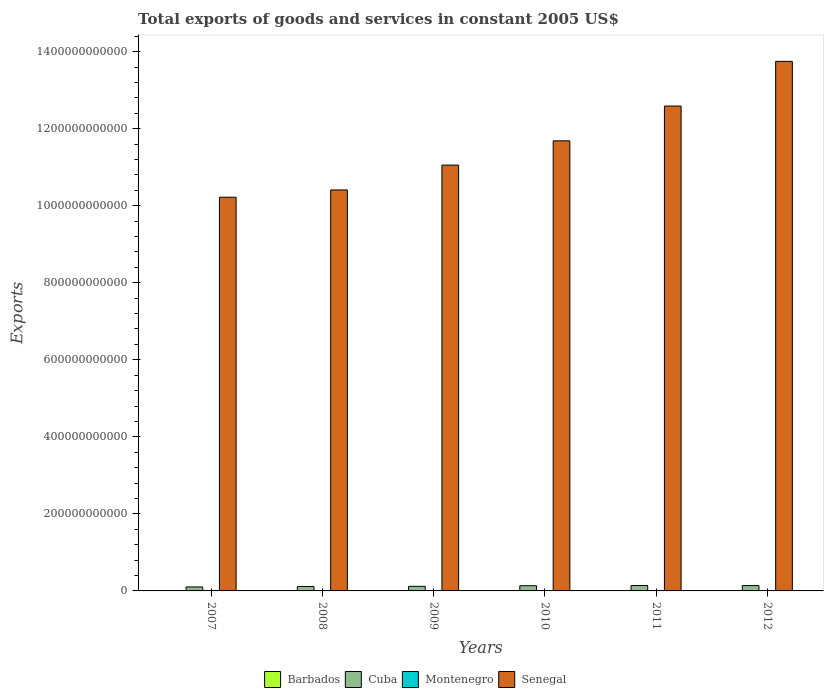How many groups of bars are there?
Keep it short and to the point. 6. Are the number of bars on each tick of the X-axis equal?
Ensure brevity in your answer.  Yes. How many bars are there on the 3rd tick from the left?
Offer a very short reply. 4. What is the label of the 5th group of bars from the left?
Keep it short and to the point. 2011. In how many cases, is the number of bars for a given year not equal to the number of legend labels?
Offer a very short reply. 0. What is the total exports of goods and services in Cuba in 2011?
Keep it short and to the point. 1.41e+1. Across all years, what is the maximum total exports of goods and services in Senegal?
Your answer should be very brief. 1.37e+12. Across all years, what is the minimum total exports of goods and services in Senegal?
Your response must be concise. 1.02e+12. In which year was the total exports of goods and services in Cuba maximum?
Your answer should be compact. 2011. What is the total total exports of goods and services in Senegal in the graph?
Make the answer very short. 6.97e+12. What is the difference between the total exports of goods and services in Cuba in 2007 and that in 2009?
Give a very brief answer. -1.56e+09. What is the difference between the total exports of goods and services in Cuba in 2007 and the total exports of goods and services in Senegal in 2008?
Your answer should be compact. -1.03e+12. What is the average total exports of goods and services in Barbados per year?
Ensure brevity in your answer.  7.30e+08. In the year 2009, what is the difference between the total exports of goods and services in Cuba and total exports of goods and services in Barbados?
Provide a succinct answer. 1.11e+1. What is the ratio of the total exports of goods and services in Barbados in 2010 to that in 2011?
Your response must be concise. 1.29. Is the difference between the total exports of goods and services in Cuba in 2009 and 2012 greater than the difference between the total exports of goods and services in Barbados in 2009 and 2012?
Your answer should be compact. No. What is the difference between the highest and the second highest total exports of goods and services in Barbados?
Ensure brevity in your answer.  2.30e+07. What is the difference between the highest and the lowest total exports of goods and services in Senegal?
Your answer should be very brief. 3.53e+11. Is it the case that in every year, the sum of the total exports of goods and services in Montenegro and total exports of goods and services in Barbados is greater than the sum of total exports of goods and services in Cuba and total exports of goods and services in Senegal?
Your response must be concise. Yes. What does the 2nd bar from the left in 2007 represents?
Provide a short and direct response. Cuba. What does the 1st bar from the right in 2012 represents?
Keep it short and to the point. Senegal. Are all the bars in the graph horizontal?
Keep it short and to the point. No. What is the difference between two consecutive major ticks on the Y-axis?
Keep it short and to the point. 2.00e+11. Are the values on the major ticks of Y-axis written in scientific E-notation?
Offer a terse response. No. Does the graph contain any zero values?
Give a very brief answer. No. Where does the legend appear in the graph?
Provide a short and direct response. Bottom center. How many legend labels are there?
Give a very brief answer. 4. How are the legend labels stacked?
Provide a succinct answer. Horizontal. What is the title of the graph?
Provide a short and direct response. Total exports of goods and services in constant 2005 US$. Does "Lithuania" appear as one of the legend labels in the graph?
Provide a short and direct response. No. What is the label or title of the X-axis?
Your response must be concise. Years. What is the label or title of the Y-axis?
Give a very brief answer. Exports. What is the Exports in Barbados in 2007?
Provide a short and direct response. 8.18e+08. What is the Exports in Cuba in 2007?
Make the answer very short. 1.03e+1. What is the Exports in Montenegro in 2007?
Your answer should be very brief. 9.66e+08. What is the Exports of Senegal in 2007?
Give a very brief answer. 1.02e+12. What is the Exports in Barbados in 2008?
Give a very brief answer. 7.82e+08. What is the Exports in Cuba in 2008?
Offer a terse response. 1.15e+1. What is the Exports of Montenegro in 2008?
Offer a terse response. 9.46e+08. What is the Exports of Senegal in 2008?
Your answer should be compact. 1.04e+12. What is the Exports in Barbados in 2009?
Offer a very short reply. 7.59e+08. What is the Exports in Cuba in 2009?
Provide a succinct answer. 1.19e+1. What is the Exports in Montenegro in 2009?
Give a very brief answer. 7.35e+08. What is the Exports of Senegal in 2009?
Your response must be concise. 1.11e+12. What is the Exports in Barbados in 2010?
Your answer should be very brief. 7.95e+08. What is the Exports of Cuba in 2010?
Your answer should be compact. 1.35e+1. What is the Exports in Montenegro in 2010?
Give a very brief answer. 7.90e+08. What is the Exports in Senegal in 2010?
Provide a short and direct response. 1.17e+12. What is the Exports of Barbados in 2011?
Provide a short and direct response. 6.14e+08. What is the Exports of Cuba in 2011?
Provide a succinct answer. 1.41e+1. What is the Exports of Montenegro in 2011?
Your answer should be compact. 9.05e+08. What is the Exports in Senegal in 2011?
Your response must be concise. 1.26e+12. What is the Exports of Barbados in 2012?
Ensure brevity in your answer.  6.13e+08. What is the Exports of Cuba in 2012?
Your response must be concise. 1.39e+1. What is the Exports of Montenegro in 2012?
Make the answer very short. 9.02e+08. What is the Exports in Senegal in 2012?
Your answer should be very brief. 1.37e+12. Across all years, what is the maximum Exports of Barbados?
Your answer should be very brief. 8.18e+08. Across all years, what is the maximum Exports of Cuba?
Give a very brief answer. 1.41e+1. Across all years, what is the maximum Exports in Montenegro?
Make the answer very short. 9.66e+08. Across all years, what is the maximum Exports of Senegal?
Offer a very short reply. 1.37e+12. Across all years, what is the minimum Exports in Barbados?
Your answer should be very brief. 6.13e+08. Across all years, what is the minimum Exports of Cuba?
Keep it short and to the point. 1.03e+1. Across all years, what is the minimum Exports of Montenegro?
Your answer should be very brief. 7.35e+08. Across all years, what is the minimum Exports in Senegal?
Provide a short and direct response. 1.02e+12. What is the total Exports of Barbados in the graph?
Your answer should be compact. 4.38e+09. What is the total Exports in Cuba in the graph?
Your answer should be compact. 7.52e+1. What is the total Exports in Montenegro in the graph?
Provide a succinct answer. 5.24e+09. What is the total Exports in Senegal in the graph?
Keep it short and to the point. 6.97e+12. What is the difference between the Exports in Barbados in 2007 and that in 2008?
Give a very brief answer. 3.60e+07. What is the difference between the Exports in Cuba in 2007 and that in 2008?
Offer a very short reply. -1.20e+09. What is the difference between the Exports in Montenegro in 2007 and that in 2008?
Your answer should be compact. 1.98e+07. What is the difference between the Exports of Senegal in 2007 and that in 2008?
Your response must be concise. -1.89e+1. What is the difference between the Exports in Barbados in 2007 and that in 2009?
Provide a short and direct response. 5.90e+07. What is the difference between the Exports of Cuba in 2007 and that in 2009?
Keep it short and to the point. -1.56e+09. What is the difference between the Exports of Montenegro in 2007 and that in 2009?
Offer a terse response. 2.31e+08. What is the difference between the Exports of Senegal in 2007 and that in 2009?
Ensure brevity in your answer.  -8.34e+1. What is the difference between the Exports of Barbados in 2007 and that in 2010?
Give a very brief answer. 2.30e+07. What is the difference between the Exports in Cuba in 2007 and that in 2010?
Offer a very short reply. -3.20e+09. What is the difference between the Exports in Montenegro in 2007 and that in 2010?
Give a very brief answer. 1.76e+08. What is the difference between the Exports in Senegal in 2007 and that in 2010?
Offer a terse response. -1.46e+11. What is the difference between the Exports in Barbados in 2007 and that in 2011?
Your response must be concise. 2.04e+08. What is the difference between the Exports in Cuba in 2007 and that in 2011?
Provide a short and direct response. -3.72e+09. What is the difference between the Exports of Montenegro in 2007 and that in 2011?
Your response must be concise. 6.07e+07. What is the difference between the Exports in Senegal in 2007 and that in 2011?
Ensure brevity in your answer.  -2.37e+11. What is the difference between the Exports in Barbados in 2007 and that in 2012?
Your response must be concise. 2.05e+08. What is the difference between the Exports of Cuba in 2007 and that in 2012?
Ensure brevity in your answer.  -3.57e+09. What is the difference between the Exports of Montenegro in 2007 and that in 2012?
Offer a terse response. 6.38e+07. What is the difference between the Exports of Senegal in 2007 and that in 2012?
Ensure brevity in your answer.  -3.53e+11. What is the difference between the Exports in Barbados in 2008 and that in 2009?
Ensure brevity in your answer.  2.30e+07. What is the difference between the Exports of Cuba in 2008 and that in 2009?
Give a very brief answer. -3.59e+08. What is the difference between the Exports in Montenegro in 2008 and that in 2009?
Your answer should be compact. 2.11e+08. What is the difference between the Exports of Senegal in 2008 and that in 2009?
Offer a terse response. -6.45e+1. What is the difference between the Exports in Barbados in 2008 and that in 2010?
Provide a succinct answer. -1.30e+07. What is the difference between the Exports of Cuba in 2008 and that in 2010?
Keep it short and to the point. -2.00e+09. What is the difference between the Exports in Montenegro in 2008 and that in 2010?
Provide a succinct answer. 1.56e+08. What is the difference between the Exports of Senegal in 2008 and that in 2010?
Keep it short and to the point. -1.27e+11. What is the difference between the Exports in Barbados in 2008 and that in 2011?
Provide a succinct answer. 1.68e+08. What is the difference between the Exports in Cuba in 2008 and that in 2011?
Make the answer very short. -2.53e+09. What is the difference between the Exports in Montenegro in 2008 and that in 2011?
Offer a terse response. 4.09e+07. What is the difference between the Exports in Senegal in 2008 and that in 2011?
Provide a succinct answer. -2.18e+11. What is the difference between the Exports of Barbados in 2008 and that in 2012?
Keep it short and to the point. 1.69e+08. What is the difference between the Exports in Cuba in 2008 and that in 2012?
Keep it short and to the point. -2.37e+09. What is the difference between the Exports of Montenegro in 2008 and that in 2012?
Your answer should be compact. 4.40e+07. What is the difference between the Exports in Senegal in 2008 and that in 2012?
Your answer should be compact. -3.34e+11. What is the difference between the Exports in Barbados in 2009 and that in 2010?
Provide a short and direct response. -3.60e+07. What is the difference between the Exports in Cuba in 2009 and that in 2010?
Provide a short and direct response. -1.64e+09. What is the difference between the Exports of Montenegro in 2009 and that in 2010?
Offer a very short reply. -5.50e+07. What is the difference between the Exports in Senegal in 2009 and that in 2010?
Give a very brief answer. -6.30e+1. What is the difference between the Exports in Barbados in 2009 and that in 2011?
Ensure brevity in your answer.  1.45e+08. What is the difference between the Exports in Cuba in 2009 and that in 2011?
Make the answer very short. -2.17e+09. What is the difference between the Exports of Montenegro in 2009 and that in 2011?
Give a very brief answer. -1.71e+08. What is the difference between the Exports of Senegal in 2009 and that in 2011?
Offer a terse response. -1.53e+11. What is the difference between the Exports of Barbados in 2009 and that in 2012?
Make the answer very short. 1.46e+08. What is the difference between the Exports in Cuba in 2009 and that in 2012?
Your response must be concise. -2.01e+09. What is the difference between the Exports in Montenegro in 2009 and that in 2012?
Offer a very short reply. -1.67e+08. What is the difference between the Exports in Senegal in 2009 and that in 2012?
Your answer should be compact. -2.69e+11. What is the difference between the Exports of Barbados in 2010 and that in 2011?
Make the answer very short. 1.81e+08. What is the difference between the Exports in Cuba in 2010 and that in 2011?
Provide a short and direct response. -5.28e+08. What is the difference between the Exports of Montenegro in 2010 and that in 2011?
Keep it short and to the point. -1.16e+08. What is the difference between the Exports in Senegal in 2010 and that in 2011?
Provide a succinct answer. -9.03e+1. What is the difference between the Exports of Barbados in 2010 and that in 2012?
Provide a succinct answer. 1.82e+08. What is the difference between the Exports in Cuba in 2010 and that in 2012?
Offer a terse response. -3.71e+08. What is the difference between the Exports in Montenegro in 2010 and that in 2012?
Your answer should be compact. -1.12e+08. What is the difference between the Exports in Senegal in 2010 and that in 2012?
Offer a terse response. -2.06e+11. What is the difference between the Exports of Cuba in 2011 and that in 2012?
Offer a very short reply. 1.57e+08. What is the difference between the Exports in Montenegro in 2011 and that in 2012?
Give a very brief answer. 3.08e+06. What is the difference between the Exports in Senegal in 2011 and that in 2012?
Provide a succinct answer. -1.16e+11. What is the difference between the Exports of Barbados in 2007 and the Exports of Cuba in 2008?
Your response must be concise. -1.07e+1. What is the difference between the Exports of Barbados in 2007 and the Exports of Montenegro in 2008?
Provide a succinct answer. -1.28e+08. What is the difference between the Exports in Barbados in 2007 and the Exports in Senegal in 2008?
Your answer should be compact. -1.04e+12. What is the difference between the Exports of Cuba in 2007 and the Exports of Montenegro in 2008?
Provide a short and direct response. 9.39e+09. What is the difference between the Exports in Cuba in 2007 and the Exports in Senegal in 2008?
Your response must be concise. -1.03e+12. What is the difference between the Exports of Montenegro in 2007 and the Exports of Senegal in 2008?
Your response must be concise. -1.04e+12. What is the difference between the Exports of Barbados in 2007 and the Exports of Cuba in 2009?
Ensure brevity in your answer.  -1.11e+1. What is the difference between the Exports in Barbados in 2007 and the Exports in Montenegro in 2009?
Offer a terse response. 8.33e+07. What is the difference between the Exports of Barbados in 2007 and the Exports of Senegal in 2009?
Provide a short and direct response. -1.10e+12. What is the difference between the Exports of Cuba in 2007 and the Exports of Montenegro in 2009?
Keep it short and to the point. 9.60e+09. What is the difference between the Exports of Cuba in 2007 and the Exports of Senegal in 2009?
Provide a short and direct response. -1.10e+12. What is the difference between the Exports of Montenegro in 2007 and the Exports of Senegal in 2009?
Ensure brevity in your answer.  -1.10e+12. What is the difference between the Exports of Barbados in 2007 and the Exports of Cuba in 2010?
Your response must be concise. -1.27e+1. What is the difference between the Exports in Barbados in 2007 and the Exports in Montenegro in 2010?
Offer a terse response. 2.83e+07. What is the difference between the Exports in Barbados in 2007 and the Exports in Senegal in 2010?
Keep it short and to the point. -1.17e+12. What is the difference between the Exports of Cuba in 2007 and the Exports of Montenegro in 2010?
Offer a terse response. 9.54e+09. What is the difference between the Exports in Cuba in 2007 and the Exports in Senegal in 2010?
Offer a very short reply. -1.16e+12. What is the difference between the Exports of Montenegro in 2007 and the Exports of Senegal in 2010?
Provide a succinct answer. -1.17e+12. What is the difference between the Exports in Barbados in 2007 and the Exports in Cuba in 2011?
Give a very brief answer. -1.32e+1. What is the difference between the Exports of Barbados in 2007 and the Exports of Montenegro in 2011?
Provide a short and direct response. -8.73e+07. What is the difference between the Exports of Barbados in 2007 and the Exports of Senegal in 2011?
Give a very brief answer. -1.26e+12. What is the difference between the Exports of Cuba in 2007 and the Exports of Montenegro in 2011?
Ensure brevity in your answer.  9.43e+09. What is the difference between the Exports in Cuba in 2007 and the Exports in Senegal in 2011?
Your answer should be very brief. -1.25e+12. What is the difference between the Exports of Montenegro in 2007 and the Exports of Senegal in 2011?
Provide a short and direct response. -1.26e+12. What is the difference between the Exports in Barbados in 2007 and the Exports in Cuba in 2012?
Offer a very short reply. -1.31e+1. What is the difference between the Exports in Barbados in 2007 and the Exports in Montenegro in 2012?
Offer a terse response. -8.42e+07. What is the difference between the Exports in Barbados in 2007 and the Exports in Senegal in 2012?
Give a very brief answer. -1.37e+12. What is the difference between the Exports in Cuba in 2007 and the Exports in Montenegro in 2012?
Ensure brevity in your answer.  9.43e+09. What is the difference between the Exports in Cuba in 2007 and the Exports in Senegal in 2012?
Keep it short and to the point. -1.36e+12. What is the difference between the Exports of Montenegro in 2007 and the Exports of Senegal in 2012?
Provide a succinct answer. -1.37e+12. What is the difference between the Exports in Barbados in 2008 and the Exports in Cuba in 2009?
Offer a terse response. -1.11e+1. What is the difference between the Exports of Barbados in 2008 and the Exports of Montenegro in 2009?
Ensure brevity in your answer.  4.73e+07. What is the difference between the Exports of Barbados in 2008 and the Exports of Senegal in 2009?
Provide a short and direct response. -1.10e+12. What is the difference between the Exports in Cuba in 2008 and the Exports in Montenegro in 2009?
Provide a short and direct response. 1.08e+1. What is the difference between the Exports of Cuba in 2008 and the Exports of Senegal in 2009?
Offer a terse response. -1.09e+12. What is the difference between the Exports in Montenegro in 2008 and the Exports in Senegal in 2009?
Offer a very short reply. -1.10e+12. What is the difference between the Exports of Barbados in 2008 and the Exports of Cuba in 2010?
Your response must be concise. -1.27e+1. What is the difference between the Exports of Barbados in 2008 and the Exports of Montenegro in 2010?
Ensure brevity in your answer.  -7.74e+06. What is the difference between the Exports in Barbados in 2008 and the Exports in Senegal in 2010?
Your answer should be very brief. -1.17e+12. What is the difference between the Exports of Cuba in 2008 and the Exports of Montenegro in 2010?
Make the answer very short. 1.07e+1. What is the difference between the Exports in Cuba in 2008 and the Exports in Senegal in 2010?
Provide a short and direct response. -1.16e+12. What is the difference between the Exports in Montenegro in 2008 and the Exports in Senegal in 2010?
Provide a succinct answer. -1.17e+12. What is the difference between the Exports in Barbados in 2008 and the Exports in Cuba in 2011?
Keep it short and to the point. -1.33e+1. What is the difference between the Exports of Barbados in 2008 and the Exports of Montenegro in 2011?
Make the answer very short. -1.23e+08. What is the difference between the Exports in Barbados in 2008 and the Exports in Senegal in 2011?
Provide a short and direct response. -1.26e+12. What is the difference between the Exports of Cuba in 2008 and the Exports of Montenegro in 2011?
Your answer should be very brief. 1.06e+1. What is the difference between the Exports of Cuba in 2008 and the Exports of Senegal in 2011?
Offer a terse response. -1.25e+12. What is the difference between the Exports of Montenegro in 2008 and the Exports of Senegal in 2011?
Provide a short and direct response. -1.26e+12. What is the difference between the Exports of Barbados in 2008 and the Exports of Cuba in 2012?
Your answer should be very brief. -1.31e+1. What is the difference between the Exports in Barbados in 2008 and the Exports in Montenegro in 2012?
Keep it short and to the point. -1.20e+08. What is the difference between the Exports in Barbados in 2008 and the Exports in Senegal in 2012?
Keep it short and to the point. -1.37e+12. What is the difference between the Exports in Cuba in 2008 and the Exports in Montenegro in 2012?
Your answer should be compact. 1.06e+1. What is the difference between the Exports of Cuba in 2008 and the Exports of Senegal in 2012?
Ensure brevity in your answer.  -1.36e+12. What is the difference between the Exports of Montenegro in 2008 and the Exports of Senegal in 2012?
Your answer should be very brief. -1.37e+12. What is the difference between the Exports of Barbados in 2009 and the Exports of Cuba in 2010?
Ensure brevity in your answer.  -1.28e+1. What is the difference between the Exports in Barbados in 2009 and the Exports in Montenegro in 2010?
Your answer should be very brief. -3.07e+07. What is the difference between the Exports in Barbados in 2009 and the Exports in Senegal in 2010?
Give a very brief answer. -1.17e+12. What is the difference between the Exports in Cuba in 2009 and the Exports in Montenegro in 2010?
Your answer should be compact. 1.11e+1. What is the difference between the Exports of Cuba in 2009 and the Exports of Senegal in 2010?
Make the answer very short. -1.16e+12. What is the difference between the Exports of Montenegro in 2009 and the Exports of Senegal in 2010?
Offer a terse response. -1.17e+12. What is the difference between the Exports in Barbados in 2009 and the Exports in Cuba in 2011?
Ensure brevity in your answer.  -1.33e+1. What is the difference between the Exports in Barbados in 2009 and the Exports in Montenegro in 2011?
Make the answer very short. -1.46e+08. What is the difference between the Exports of Barbados in 2009 and the Exports of Senegal in 2011?
Provide a short and direct response. -1.26e+12. What is the difference between the Exports in Cuba in 2009 and the Exports in Montenegro in 2011?
Your response must be concise. 1.10e+1. What is the difference between the Exports in Cuba in 2009 and the Exports in Senegal in 2011?
Your answer should be compact. -1.25e+12. What is the difference between the Exports in Montenegro in 2009 and the Exports in Senegal in 2011?
Provide a succinct answer. -1.26e+12. What is the difference between the Exports in Barbados in 2009 and the Exports in Cuba in 2012?
Keep it short and to the point. -1.31e+1. What is the difference between the Exports in Barbados in 2009 and the Exports in Montenegro in 2012?
Ensure brevity in your answer.  -1.43e+08. What is the difference between the Exports of Barbados in 2009 and the Exports of Senegal in 2012?
Provide a short and direct response. -1.37e+12. What is the difference between the Exports in Cuba in 2009 and the Exports in Montenegro in 2012?
Give a very brief answer. 1.10e+1. What is the difference between the Exports of Cuba in 2009 and the Exports of Senegal in 2012?
Give a very brief answer. -1.36e+12. What is the difference between the Exports in Montenegro in 2009 and the Exports in Senegal in 2012?
Provide a short and direct response. -1.37e+12. What is the difference between the Exports in Barbados in 2010 and the Exports in Cuba in 2011?
Provide a short and direct response. -1.33e+1. What is the difference between the Exports of Barbados in 2010 and the Exports of Montenegro in 2011?
Make the answer very short. -1.10e+08. What is the difference between the Exports in Barbados in 2010 and the Exports in Senegal in 2011?
Ensure brevity in your answer.  -1.26e+12. What is the difference between the Exports of Cuba in 2010 and the Exports of Montenegro in 2011?
Ensure brevity in your answer.  1.26e+1. What is the difference between the Exports of Cuba in 2010 and the Exports of Senegal in 2011?
Give a very brief answer. -1.25e+12. What is the difference between the Exports of Montenegro in 2010 and the Exports of Senegal in 2011?
Your response must be concise. -1.26e+12. What is the difference between the Exports in Barbados in 2010 and the Exports in Cuba in 2012?
Ensure brevity in your answer.  -1.31e+1. What is the difference between the Exports in Barbados in 2010 and the Exports in Montenegro in 2012?
Offer a terse response. -1.07e+08. What is the difference between the Exports in Barbados in 2010 and the Exports in Senegal in 2012?
Keep it short and to the point. -1.37e+12. What is the difference between the Exports in Cuba in 2010 and the Exports in Montenegro in 2012?
Provide a succinct answer. 1.26e+1. What is the difference between the Exports in Cuba in 2010 and the Exports in Senegal in 2012?
Provide a succinct answer. -1.36e+12. What is the difference between the Exports of Montenegro in 2010 and the Exports of Senegal in 2012?
Keep it short and to the point. -1.37e+12. What is the difference between the Exports of Barbados in 2011 and the Exports of Cuba in 2012?
Ensure brevity in your answer.  -1.33e+1. What is the difference between the Exports of Barbados in 2011 and the Exports of Montenegro in 2012?
Ensure brevity in your answer.  -2.88e+08. What is the difference between the Exports of Barbados in 2011 and the Exports of Senegal in 2012?
Provide a short and direct response. -1.37e+12. What is the difference between the Exports in Cuba in 2011 and the Exports in Montenegro in 2012?
Your answer should be compact. 1.32e+1. What is the difference between the Exports in Cuba in 2011 and the Exports in Senegal in 2012?
Ensure brevity in your answer.  -1.36e+12. What is the difference between the Exports in Montenegro in 2011 and the Exports in Senegal in 2012?
Offer a very short reply. -1.37e+12. What is the average Exports in Barbados per year?
Make the answer very short. 7.30e+08. What is the average Exports in Cuba per year?
Your response must be concise. 1.25e+1. What is the average Exports in Montenegro per year?
Provide a short and direct response. 8.74e+08. What is the average Exports of Senegal per year?
Provide a short and direct response. 1.16e+12. In the year 2007, what is the difference between the Exports in Barbados and Exports in Cuba?
Provide a succinct answer. -9.52e+09. In the year 2007, what is the difference between the Exports of Barbados and Exports of Montenegro?
Provide a short and direct response. -1.48e+08. In the year 2007, what is the difference between the Exports of Barbados and Exports of Senegal?
Your response must be concise. -1.02e+12. In the year 2007, what is the difference between the Exports of Cuba and Exports of Montenegro?
Offer a very short reply. 9.37e+09. In the year 2007, what is the difference between the Exports in Cuba and Exports in Senegal?
Your answer should be compact. -1.01e+12. In the year 2007, what is the difference between the Exports of Montenegro and Exports of Senegal?
Your response must be concise. -1.02e+12. In the year 2008, what is the difference between the Exports in Barbados and Exports in Cuba?
Your response must be concise. -1.07e+1. In the year 2008, what is the difference between the Exports of Barbados and Exports of Montenegro?
Your response must be concise. -1.64e+08. In the year 2008, what is the difference between the Exports in Barbados and Exports in Senegal?
Give a very brief answer. -1.04e+12. In the year 2008, what is the difference between the Exports in Cuba and Exports in Montenegro?
Your answer should be compact. 1.06e+1. In the year 2008, what is the difference between the Exports of Cuba and Exports of Senegal?
Provide a short and direct response. -1.03e+12. In the year 2008, what is the difference between the Exports in Montenegro and Exports in Senegal?
Give a very brief answer. -1.04e+12. In the year 2009, what is the difference between the Exports in Barbados and Exports in Cuba?
Provide a short and direct response. -1.11e+1. In the year 2009, what is the difference between the Exports of Barbados and Exports of Montenegro?
Make the answer very short. 2.43e+07. In the year 2009, what is the difference between the Exports of Barbados and Exports of Senegal?
Your response must be concise. -1.10e+12. In the year 2009, what is the difference between the Exports in Cuba and Exports in Montenegro?
Provide a succinct answer. 1.12e+1. In the year 2009, what is the difference between the Exports in Cuba and Exports in Senegal?
Provide a succinct answer. -1.09e+12. In the year 2009, what is the difference between the Exports in Montenegro and Exports in Senegal?
Your answer should be very brief. -1.10e+12. In the year 2010, what is the difference between the Exports in Barbados and Exports in Cuba?
Your response must be concise. -1.27e+1. In the year 2010, what is the difference between the Exports in Barbados and Exports in Montenegro?
Provide a succinct answer. 5.26e+06. In the year 2010, what is the difference between the Exports of Barbados and Exports of Senegal?
Offer a terse response. -1.17e+12. In the year 2010, what is the difference between the Exports in Cuba and Exports in Montenegro?
Make the answer very short. 1.27e+1. In the year 2010, what is the difference between the Exports in Cuba and Exports in Senegal?
Your answer should be compact. -1.15e+12. In the year 2010, what is the difference between the Exports in Montenegro and Exports in Senegal?
Your response must be concise. -1.17e+12. In the year 2011, what is the difference between the Exports in Barbados and Exports in Cuba?
Offer a terse response. -1.34e+1. In the year 2011, what is the difference between the Exports in Barbados and Exports in Montenegro?
Keep it short and to the point. -2.91e+08. In the year 2011, what is the difference between the Exports in Barbados and Exports in Senegal?
Offer a terse response. -1.26e+12. In the year 2011, what is the difference between the Exports in Cuba and Exports in Montenegro?
Offer a terse response. 1.32e+1. In the year 2011, what is the difference between the Exports of Cuba and Exports of Senegal?
Your answer should be compact. -1.24e+12. In the year 2011, what is the difference between the Exports in Montenegro and Exports in Senegal?
Your answer should be compact. -1.26e+12. In the year 2012, what is the difference between the Exports in Barbados and Exports in Cuba?
Ensure brevity in your answer.  -1.33e+1. In the year 2012, what is the difference between the Exports of Barbados and Exports of Montenegro?
Keep it short and to the point. -2.89e+08. In the year 2012, what is the difference between the Exports in Barbados and Exports in Senegal?
Your response must be concise. -1.37e+12. In the year 2012, what is the difference between the Exports of Cuba and Exports of Montenegro?
Offer a terse response. 1.30e+1. In the year 2012, what is the difference between the Exports in Cuba and Exports in Senegal?
Your answer should be very brief. -1.36e+12. In the year 2012, what is the difference between the Exports in Montenegro and Exports in Senegal?
Your answer should be very brief. -1.37e+12. What is the ratio of the Exports in Barbados in 2007 to that in 2008?
Keep it short and to the point. 1.05. What is the ratio of the Exports of Cuba in 2007 to that in 2008?
Offer a terse response. 0.9. What is the ratio of the Exports of Montenegro in 2007 to that in 2008?
Ensure brevity in your answer.  1.02. What is the ratio of the Exports of Senegal in 2007 to that in 2008?
Offer a terse response. 0.98. What is the ratio of the Exports in Barbados in 2007 to that in 2009?
Give a very brief answer. 1.08. What is the ratio of the Exports of Cuba in 2007 to that in 2009?
Your answer should be very brief. 0.87. What is the ratio of the Exports of Montenegro in 2007 to that in 2009?
Ensure brevity in your answer.  1.31. What is the ratio of the Exports of Senegal in 2007 to that in 2009?
Ensure brevity in your answer.  0.92. What is the ratio of the Exports in Barbados in 2007 to that in 2010?
Your answer should be compact. 1.03. What is the ratio of the Exports of Cuba in 2007 to that in 2010?
Your answer should be compact. 0.76. What is the ratio of the Exports of Montenegro in 2007 to that in 2010?
Keep it short and to the point. 1.22. What is the ratio of the Exports of Senegal in 2007 to that in 2010?
Your answer should be compact. 0.87. What is the ratio of the Exports of Barbados in 2007 to that in 2011?
Provide a short and direct response. 1.33. What is the ratio of the Exports of Cuba in 2007 to that in 2011?
Ensure brevity in your answer.  0.74. What is the ratio of the Exports in Montenegro in 2007 to that in 2011?
Give a very brief answer. 1.07. What is the ratio of the Exports of Senegal in 2007 to that in 2011?
Your response must be concise. 0.81. What is the ratio of the Exports of Barbados in 2007 to that in 2012?
Your response must be concise. 1.33. What is the ratio of the Exports of Cuba in 2007 to that in 2012?
Your answer should be compact. 0.74. What is the ratio of the Exports of Montenegro in 2007 to that in 2012?
Give a very brief answer. 1.07. What is the ratio of the Exports of Senegal in 2007 to that in 2012?
Offer a terse response. 0.74. What is the ratio of the Exports of Barbados in 2008 to that in 2009?
Provide a short and direct response. 1.03. What is the ratio of the Exports in Cuba in 2008 to that in 2009?
Offer a very short reply. 0.97. What is the ratio of the Exports of Montenegro in 2008 to that in 2009?
Keep it short and to the point. 1.29. What is the ratio of the Exports in Senegal in 2008 to that in 2009?
Provide a short and direct response. 0.94. What is the ratio of the Exports in Barbados in 2008 to that in 2010?
Make the answer very short. 0.98. What is the ratio of the Exports in Cuba in 2008 to that in 2010?
Your answer should be compact. 0.85. What is the ratio of the Exports in Montenegro in 2008 to that in 2010?
Give a very brief answer. 1.2. What is the ratio of the Exports in Senegal in 2008 to that in 2010?
Offer a terse response. 0.89. What is the ratio of the Exports of Barbados in 2008 to that in 2011?
Give a very brief answer. 1.27. What is the ratio of the Exports in Cuba in 2008 to that in 2011?
Your response must be concise. 0.82. What is the ratio of the Exports of Montenegro in 2008 to that in 2011?
Keep it short and to the point. 1.05. What is the ratio of the Exports in Senegal in 2008 to that in 2011?
Ensure brevity in your answer.  0.83. What is the ratio of the Exports of Barbados in 2008 to that in 2012?
Offer a very short reply. 1.28. What is the ratio of the Exports of Cuba in 2008 to that in 2012?
Keep it short and to the point. 0.83. What is the ratio of the Exports of Montenegro in 2008 to that in 2012?
Provide a short and direct response. 1.05. What is the ratio of the Exports in Senegal in 2008 to that in 2012?
Provide a short and direct response. 0.76. What is the ratio of the Exports of Barbados in 2009 to that in 2010?
Offer a very short reply. 0.95. What is the ratio of the Exports of Cuba in 2009 to that in 2010?
Provide a succinct answer. 0.88. What is the ratio of the Exports of Montenegro in 2009 to that in 2010?
Your response must be concise. 0.93. What is the ratio of the Exports in Senegal in 2009 to that in 2010?
Make the answer very short. 0.95. What is the ratio of the Exports in Barbados in 2009 to that in 2011?
Provide a succinct answer. 1.24. What is the ratio of the Exports of Cuba in 2009 to that in 2011?
Keep it short and to the point. 0.85. What is the ratio of the Exports in Montenegro in 2009 to that in 2011?
Ensure brevity in your answer.  0.81. What is the ratio of the Exports in Senegal in 2009 to that in 2011?
Keep it short and to the point. 0.88. What is the ratio of the Exports in Barbados in 2009 to that in 2012?
Provide a succinct answer. 1.24. What is the ratio of the Exports in Cuba in 2009 to that in 2012?
Provide a succinct answer. 0.86. What is the ratio of the Exports in Montenegro in 2009 to that in 2012?
Keep it short and to the point. 0.81. What is the ratio of the Exports in Senegal in 2009 to that in 2012?
Provide a short and direct response. 0.8. What is the ratio of the Exports in Barbados in 2010 to that in 2011?
Provide a short and direct response. 1.29. What is the ratio of the Exports in Cuba in 2010 to that in 2011?
Offer a terse response. 0.96. What is the ratio of the Exports in Montenegro in 2010 to that in 2011?
Your answer should be very brief. 0.87. What is the ratio of the Exports of Senegal in 2010 to that in 2011?
Your answer should be very brief. 0.93. What is the ratio of the Exports in Barbados in 2010 to that in 2012?
Your response must be concise. 1.3. What is the ratio of the Exports in Cuba in 2010 to that in 2012?
Give a very brief answer. 0.97. What is the ratio of the Exports in Montenegro in 2010 to that in 2012?
Provide a succinct answer. 0.88. What is the ratio of the Exports of Senegal in 2010 to that in 2012?
Your answer should be very brief. 0.85. What is the ratio of the Exports of Cuba in 2011 to that in 2012?
Provide a succinct answer. 1.01. What is the ratio of the Exports of Senegal in 2011 to that in 2012?
Your answer should be very brief. 0.92. What is the difference between the highest and the second highest Exports of Barbados?
Provide a short and direct response. 2.30e+07. What is the difference between the highest and the second highest Exports of Cuba?
Provide a short and direct response. 1.57e+08. What is the difference between the highest and the second highest Exports of Montenegro?
Provide a succinct answer. 1.98e+07. What is the difference between the highest and the second highest Exports of Senegal?
Ensure brevity in your answer.  1.16e+11. What is the difference between the highest and the lowest Exports in Barbados?
Your answer should be very brief. 2.05e+08. What is the difference between the highest and the lowest Exports of Cuba?
Your answer should be very brief. 3.72e+09. What is the difference between the highest and the lowest Exports of Montenegro?
Offer a very short reply. 2.31e+08. What is the difference between the highest and the lowest Exports of Senegal?
Provide a short and direct response. 3.53e+11. 